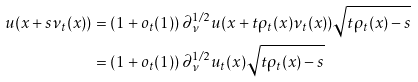Convert formula to latex. <formula><loc_0><loc_0><loc_500><loc_500>u ( x + s \nu _ { t } ( x ) ) & = ( 1 + o _ { t } ( 1 ) ) \, \partial ^ { 1 / 2 } _ { \nu } u ( x + t { \rho _ { t } } ( x ) \nu _ { t } ( x ) ) \sqrt { t { \rho _ { t } } ( x ) - s } \\ & = ( 1 + o _ { t } ( 1 ) ) \, \partial ^ { 1 / 2 } _ { \nu } u _ { t } ( x ) \sqrt { t { \rho _ { t } } ( x ) - s }</formula> 